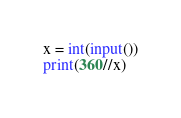<code> <loc_0><loc_0><loc_500><loc_500><_Python_>x = int(input())
print(360//x)</code> 